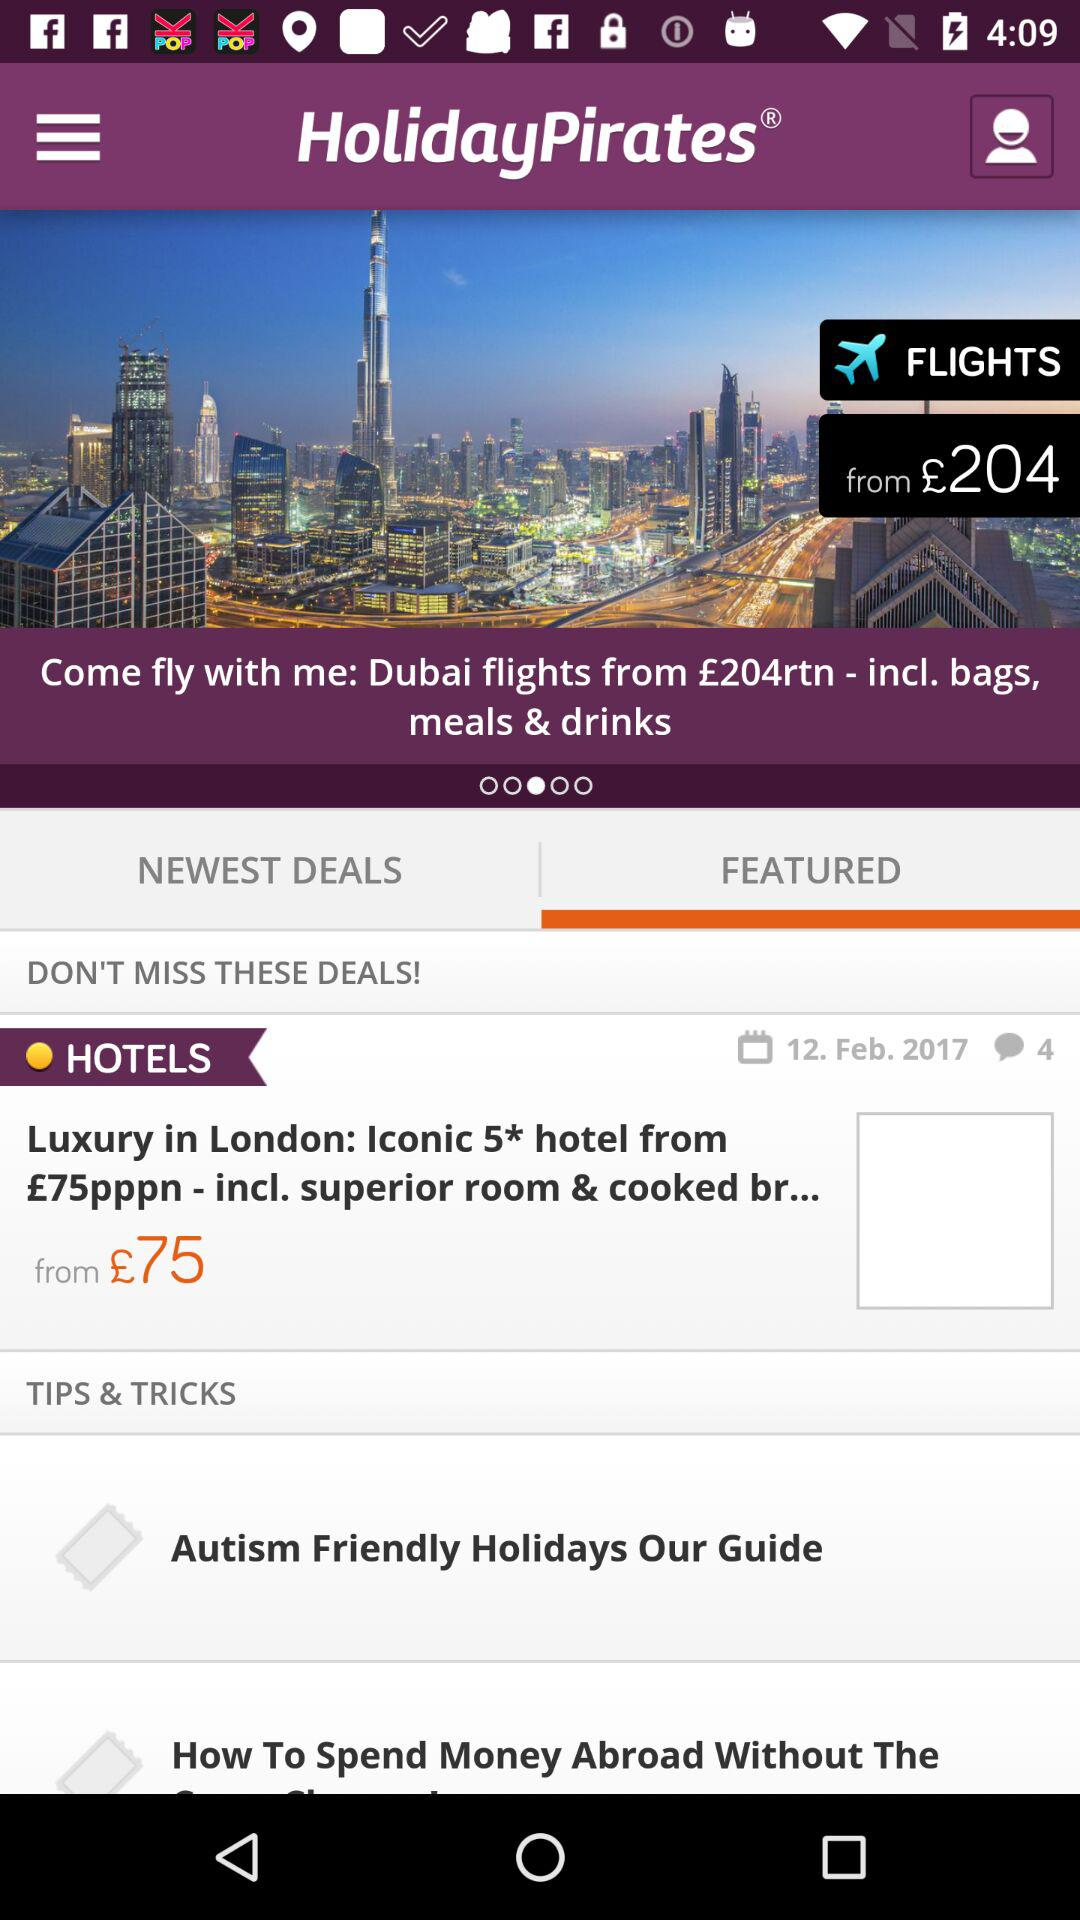How many comments are there for hotels? There are 4 comments. 